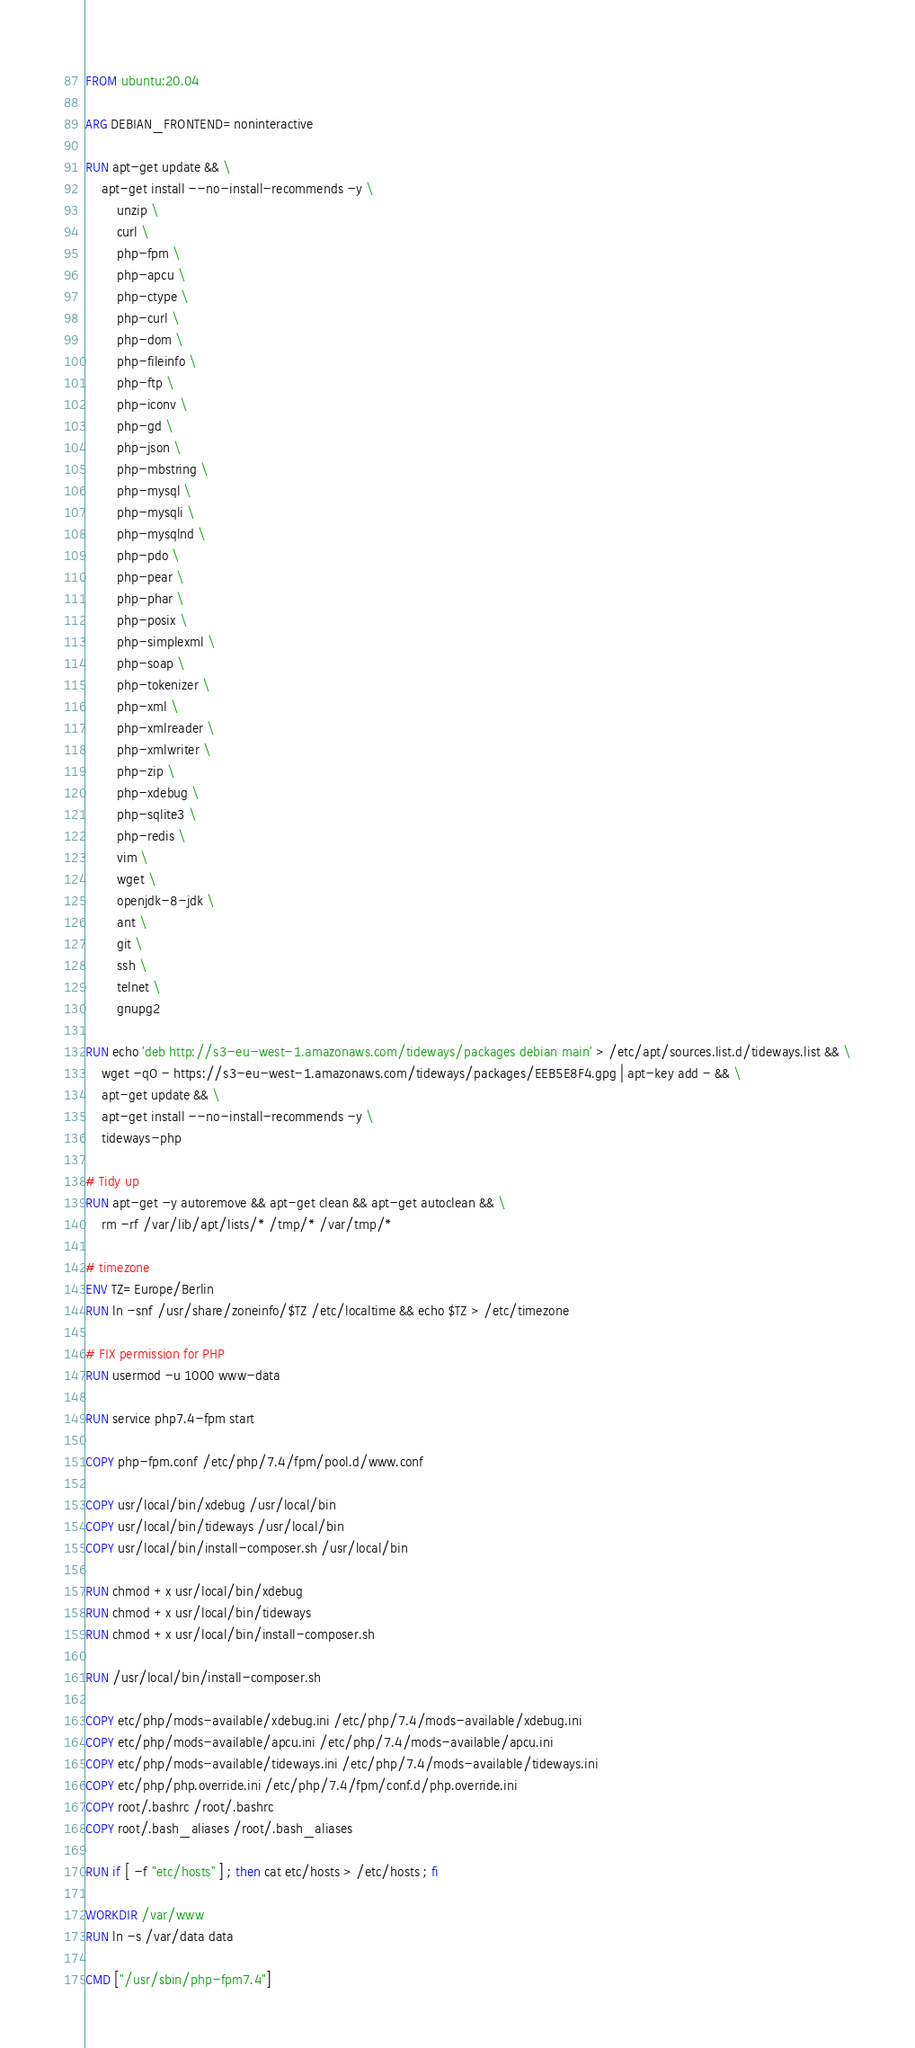<code> <loc_0><loc_0><loc_500><loc_500><_Dockerfile_>FROM ubuntu:20.04

ARG DEBIAN_FRONTEND=noninteractive

RUN apt-get update && \
    apt-get install --no-install-recommends -y \
        unzip \
        curl \
        php-fpm \
        php-apcu \
        php-ctype \
        php-curl \
        php-dom \
        php-fileinfo \
        php-ftp \
        php-iconv \
        php-gd \
        php-json \
        php-mbstring \
        php-mysql \
        php-mysqli \
        php-mysqlnd \
        php-pdo \
        php-pear \
        php-phar \
        php-posix \
        php-simplexml \
        php-soap \
        php-tokenizer \
        php-xml \
        php-xmlreader \
        php-xmlwriter \
        php-zip \
        php-xdebug \
        php-sqlite3 \
        php-redis \
        vim \
        wget \
        openjdk-8-jdk \
        ant \
        git \
        ssh \
        telnet \
        gnupg2

RUN echo 'deb http://s3-eu-west-1.amazonaws.com/tideways/packages debian main' > /etc/apt/sources.list.d/tideways.list && \
    wget -qO - https://s3-eu-west-1.amazonaws.com/tideways/packages/EEB5E8F4.gpg | apt-key add - && \
    apt-get update && \
    apt-get install --no-install-recommends -y \
    tideways-php

# Tidy up
RUN apt-get -y autoremove && apt-get clean && apt-get autoclean && \
    rm -rf /var/lib/apt/lists/* /tmp/* /var/tmp/*

# timezone
ENV TZ=Europe/Berlin
RUN ln -snf /usr/share/zoneinfo/$TZ /etc/localtime && echo $TZ > /etc/timezone

# FIX permission for PHP
RUN usermod -u 1000 www-data

RUN service php7.4-fpm start

COPY php-fpm.conf /etc/php/7.4/fpm/pool.d/www.conf

COPY usr/local/bin/xdebug /usr/local/bin
COPY usr/local/bin/tideways /usr/local/bin
COPY usr/local/bin/install-composer.sh /usr/local/bin

RUN chmod +x usr/local/bin/xdebug
RUN chmod +x usr/local/bin/tideways
RUN chmod +x usr/local/bin/install-composer.sh

RUN /usr/local/bin/install-composer.sh

COPY etc/php/mods-available/xdebug.ini /etc/php/7.4/mods-available/xdebug.ini
COPY etc/php/mods-available/apcu.ini /etc/php/7.4/mods-available/apcu.ini
COPY etc/php/mods-available/tideways.ini /etc/php/7.4/mods-available/tideways.ini
COPY etc/php/php.override.ini /etc/php/7.4/fpm/conf.d/php.override.ini
COPY root/.bashrc /root/.bashrc
COPY root/.bash_aliases /root/.bash_aliases

RUN if [ -f "etc/hosts" ] ; then cat etc/hosts > /etc/hosts ; fi

WORKDIR /var/www
RUN ln -s /var/data data

CMD ["/usr/sbin/php-fpm7.4"]</code> 